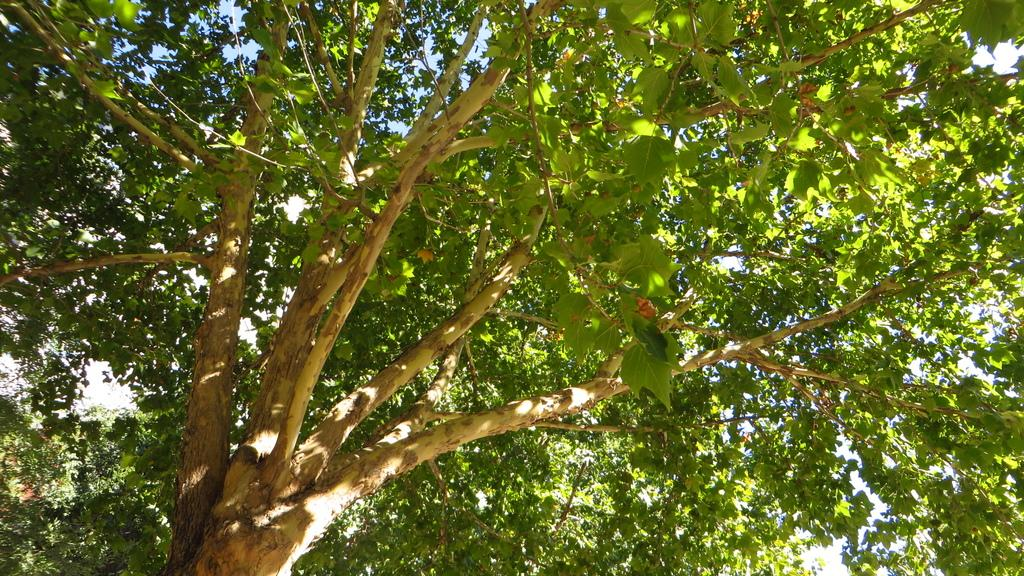What is the main subject in the center of the image? There is a tree in the center of the image. What can be seen in the background of the image? The sky is visible in the background of the image. What type of curtain can be seen hanging from the tree in the image? There is no curtain present in the image; it features a tree and the sky in the background. 